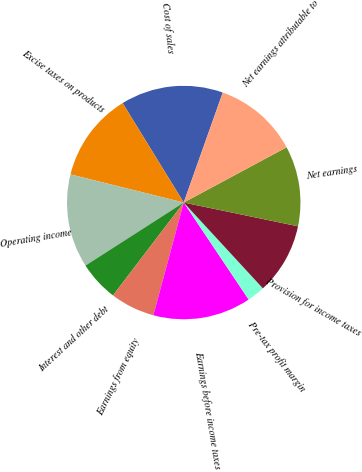Convert chart. <chart><loc_0><loc_0><loc_500><loc_500><pie_chart><fcel>Cost of sales<fcel>Excise taxes on products<fcel>Operating income<fcel>Interest and other debt<fcel>Earnings from equity<fcel>Earnings before income taxes<fcel>Pre-tax profit margin<fcel>Provision for income taxes<fcel>Net earnings<fcel>Net earnings attributable to<nl><fcel>14.2%<fcel>12.35%<fcel>12.96%<fcel>5.56%<fcel>6.17%<fcel>13.58%<fcel>2.47%<fcel>9.88%<fcel>11.11%<fcel>11.73%<nl></chart> 